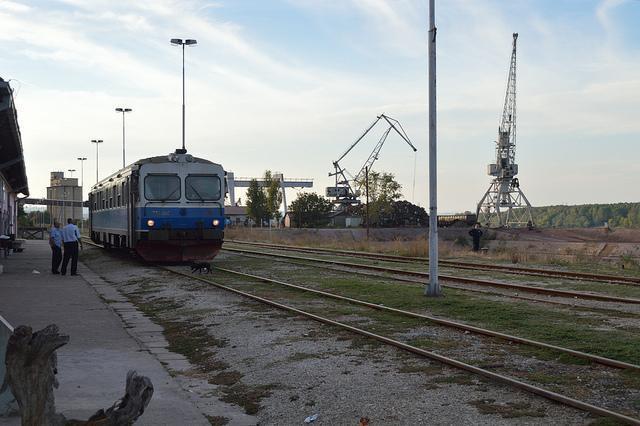How many people are in this photo?
Give a very brief answer. 2. How many sets of tracks?
Give a very brief answer. 3. How many sets of tracks are there?
Give a very brief answer. 3. 